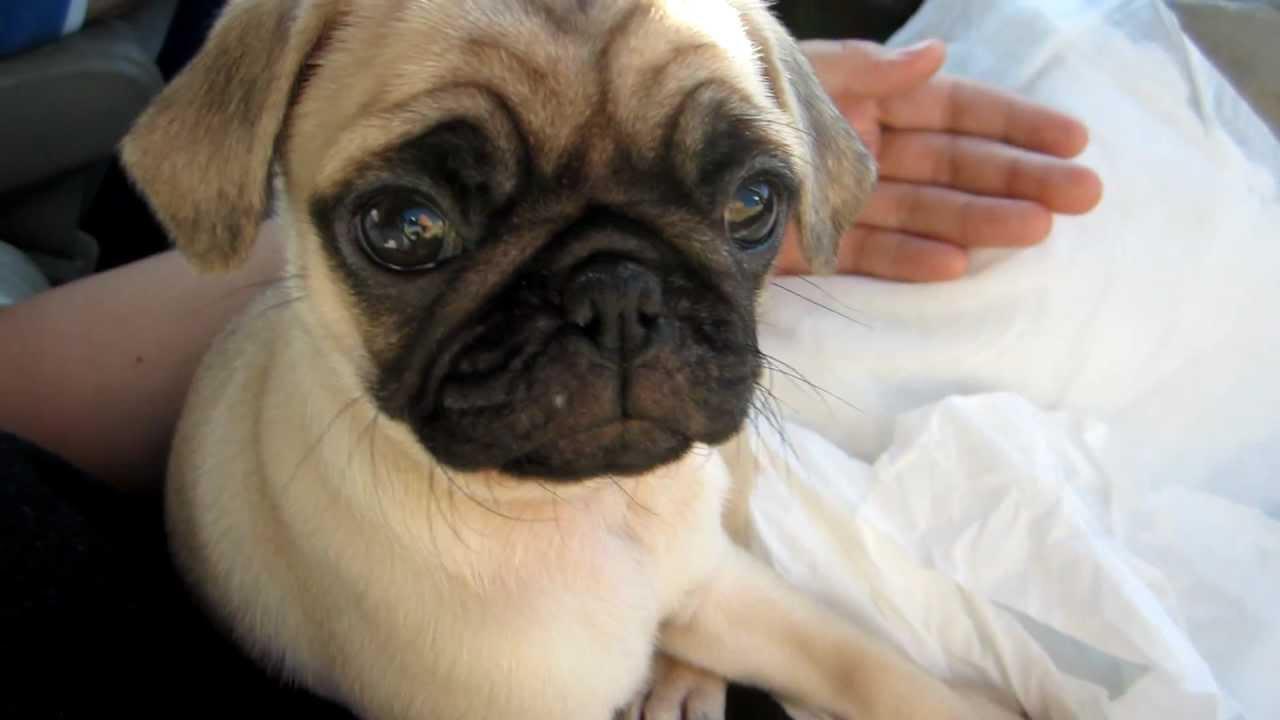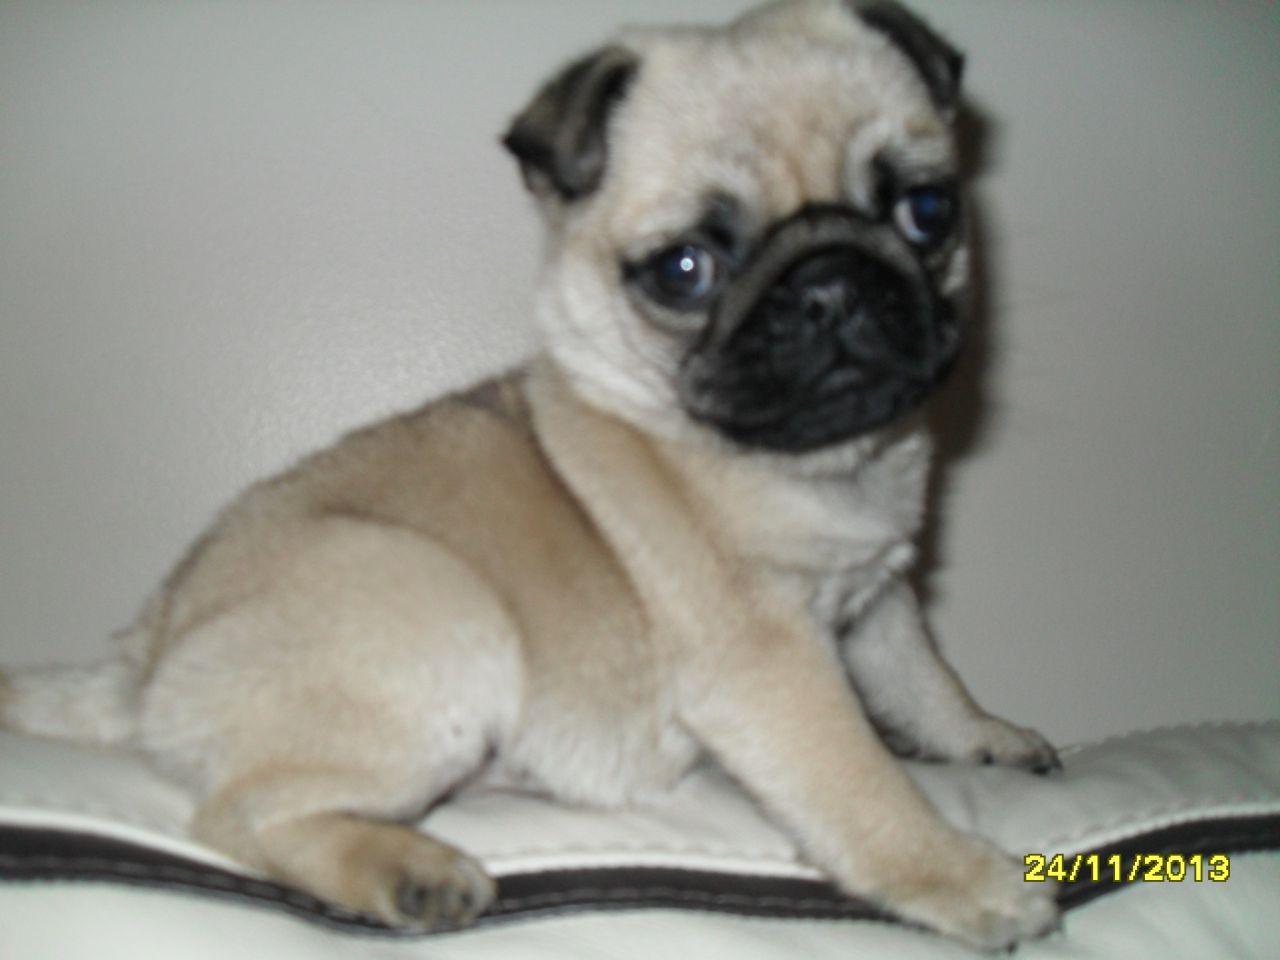The first image is the image on the left, the second image is the image on the right. Assess this claim about the two images: "An image shows just one pug dog on a leather-type seat.". Correct or not? Answer yes or no. No. 